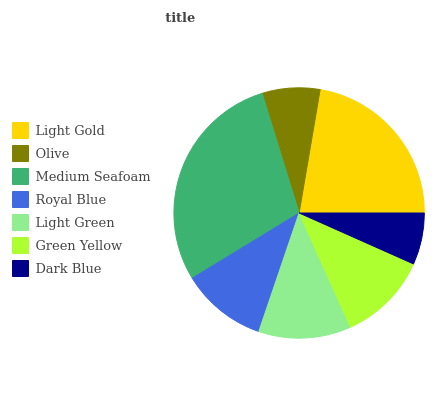Is Dark Blue the minimum?
Answer yes or no. Yes. Is Medium Seafoam the maximum?
Answer yes or no. Yes. Is Olive the minimum?
Answer yes or no. No. Is Olive the maximum?
Answer yes or no. No. Is Light Gold greater than Olive?
Answer yes or no. Yes. Is Olive less than Light Gold?
Answer yes or no. Yes. Is Olive greater than Light Gold?
Answer yes or no. No. Is Light Gold less than Olive?
Answer yes or no. No. Is Green Yellow the high median?
Answer yes or no. Yes. Is Green Yellow the low median?
Answer yes or no. Yes. Is Light Gold the high median?
Answer yes or no. No. Is Medium Seafoam the low median?
Answer yes or no. No. 